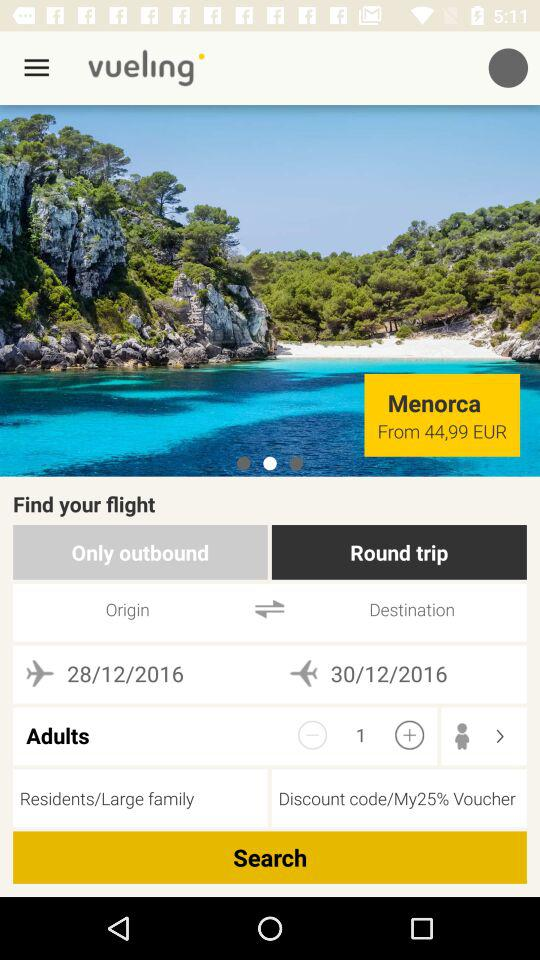What is the name of the application? The name of the application is "vueling". 